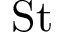Convert formula to latex. <formula><loc_0><loc_0><loc_500><loc_500>S t</formula> 